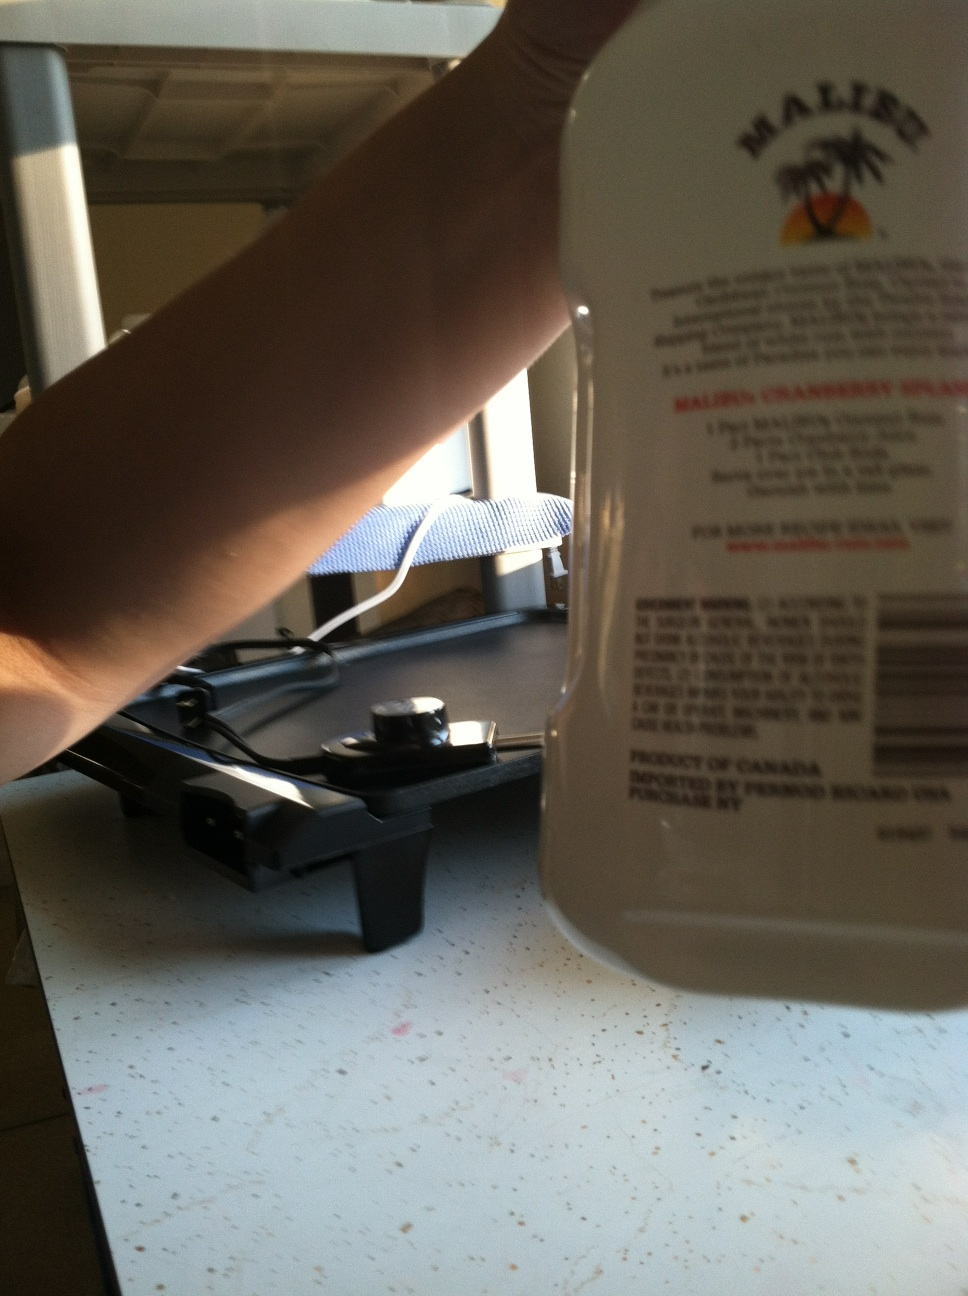What can you tell me about the product's origin from the label? The label on the bottle states that the product is made in Canada and produced by Marico Beverages. It suggests that this is an international brand of flavored alcoholic drinks. 